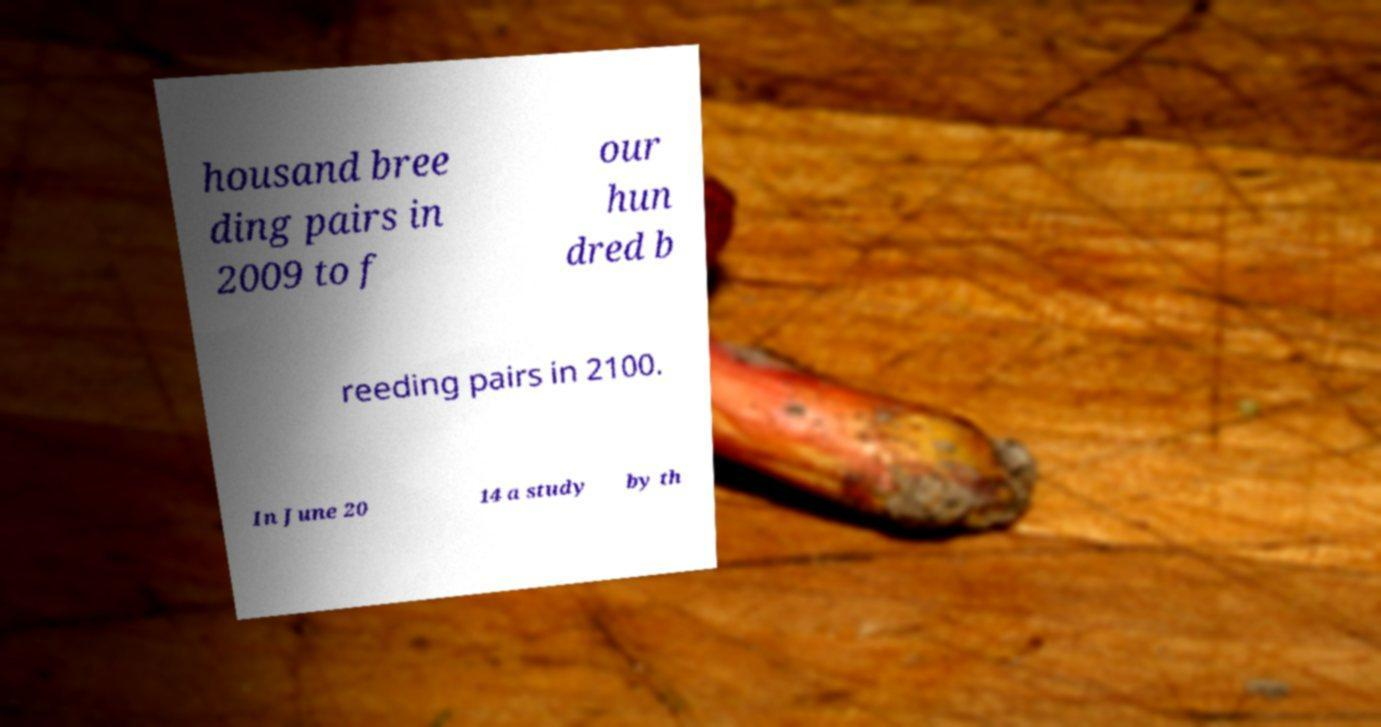Could you extract and type out the text from this image? housand bree ding pairs in 2009 to f our hun dred b reeding pairs in 2100. In June 20 14 a study by th 